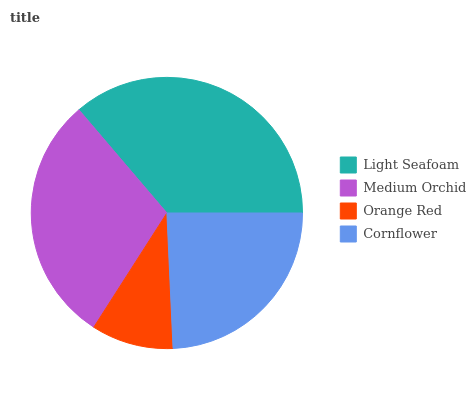Is Orange Red the minimum?
Answer yes or no. Yes. Is Light Seafoam the maximum?
Answer yes or no. Yes. Is Medium Orchid the minimum?
Answer yes or no. No. Is Medium Orchid the maximum?
Answer yes or no. No. Is Light Seafoam greater than Medium Orchid?
Answer yes or no. Yes. Is Medium Orchid less than Light Seafoam?
Answer yes or no. Yes. Is Medium Orchid greater than Light Seafoam?
Answer yes or no. No. Is Light Seafoam less than Medium Orchid?
Answer yes or no. No. Is Medium Orchid the high median?
Answer yes or no. Yes. Is Cornflower the low median?
Answer yes or no. Yes. Is Cornflower the high median?
Answer yes or no. No. Is Light Seafoam the low median?
Answer yes or no. No. 